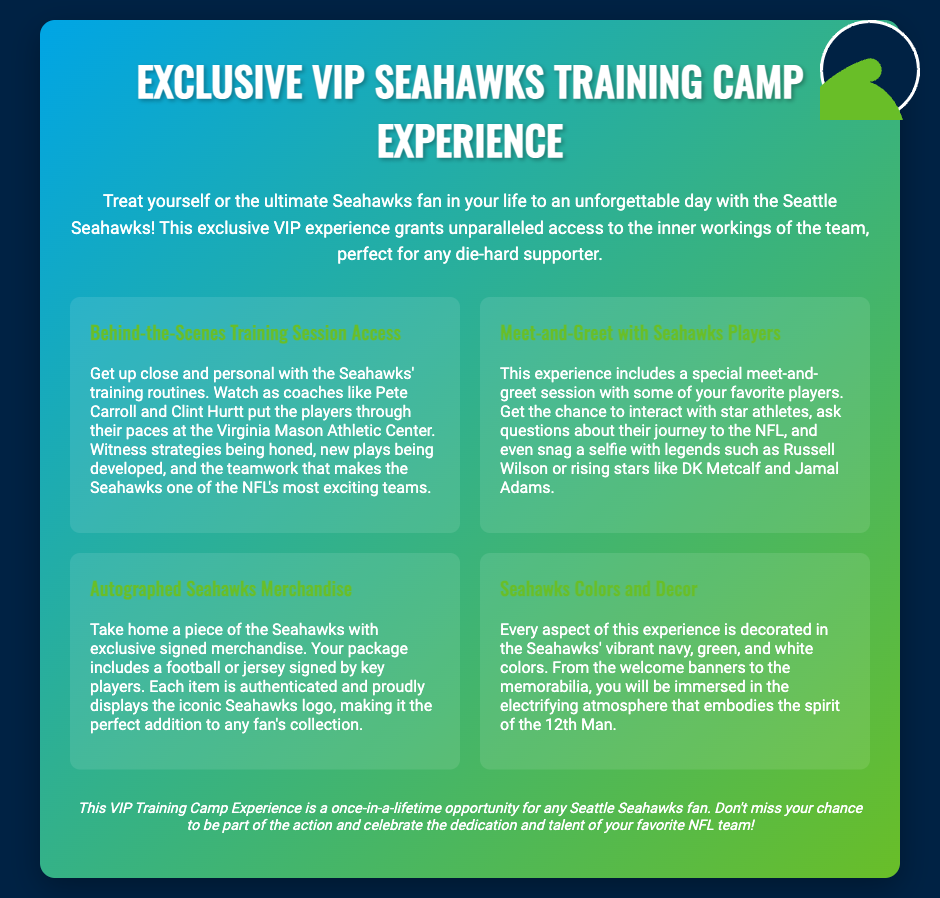What is the title of the experience? The title can be found prominently at the top of the document within the header.
Answer: Exclusive VIP Seahawks Training Camp Experience What is included in the meet-and-greet? The document specifies that attendees will get to interact with players and ask questions about their journey to the NFL.
Answer: Interaction with players What color scheme is used for the voucher? The document describes the colors that dominate the design and decorations of the experience.
Answer: Navy, green, and white Which players are mentioned as possible meet-and-greet participants? The document lists specific players that attendees may have the chance to meet during the experience.
Answer: Russell Wilson, DK Metcalf, Jamal Adams What type of merchandise is provided? The document specifies the kind of items that will be autographed and included in the experience package.
Answer: Football or jersey What location hosts the training sessions? The document identifies the venue where the training sessions take place.
Answer: Virginia Mason Athletic Center How does the experience highlight the spirit of the fans? The document mentions that the experience is decorated to embody the spirit of a specific fan group.
Answer: Spirit of the 12th Man What is the purpose of this VIP experience? The introduction describes the overall intent of the experience catered to fans of the team.
Answer: Unforgettable access to the Seahawks 